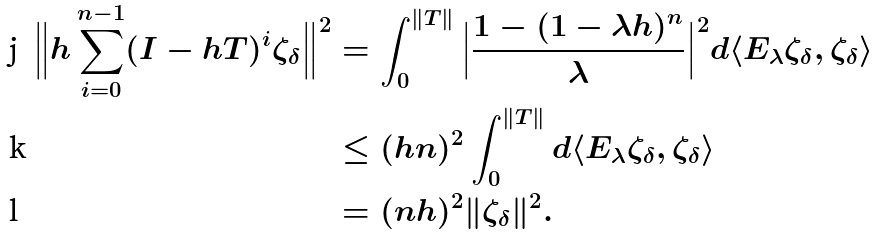<formula> <loc_0><loc_0><loc_500><loc_500>\Big { \| } h \sum _ { i = 0 } ^ { n - 1 } ( I - h T ) ^ { i } \zeta _ { \delta } \Big { \| } ^ { 2 } & = \int _ { 0 } ^ { \| T \| } \Big { | } \frac { 1 - ( 1 - \lambda h ) ^ { n } } { \lambda } \Big { | } ^ { 2 } d \langle E _ { \lambda } \zeta _ { \delta } , \zeta _ { \delta } \rangle \\ & \leq ( h n ) ^ { 2 } \int _ { 0 } ^ { \| T \| } d \langle E _ { \lambda } \zeta _ { \delta } , \zeta _ { \delta } \rangle \\ & = ( n h ) ^ { 2 } \| \zeta _ { \delta } \| ^ { 2 } .</formula> 